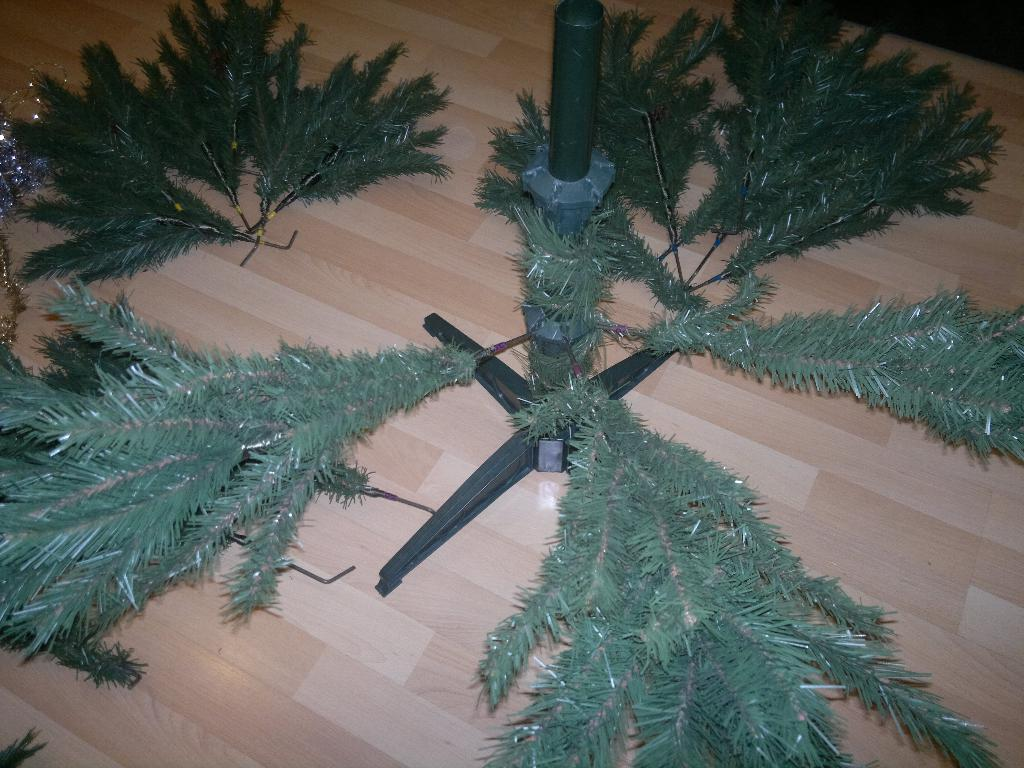What type of vegetation can be seen in the image? There are leaves in the image. What structure is present in the image? There is a pole in the image. What type of furniture is visible in the image? There is a wooden table in the image. What type of destruction can be seen in the image? There is no destruction present in the image; it features leaves, a pole, and a wooden table. What type of zephyr can be seen in the image? There is no zephyr present in the image; a zephyr is a gentle breeze, and there is no reference to weather or wind in the image. 